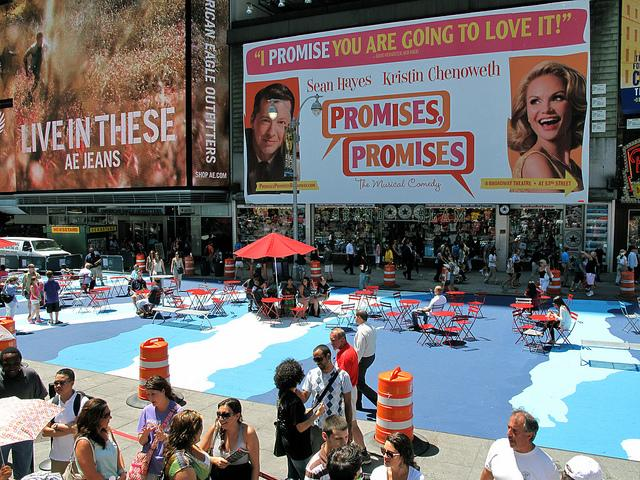What type traffic is allowed to go through this street at this time? Please explain your reasoning. foot only. People are walking around the street and sitting in chairs on the street. 